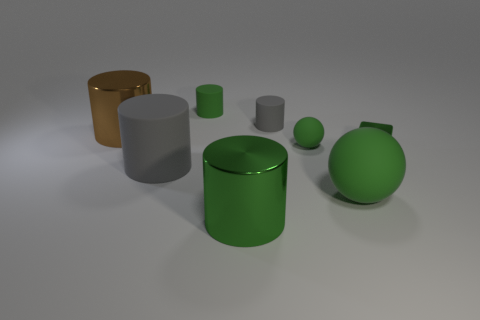Is the color of the big metal object that is to the right of the brown object the same as the small shiny thing?
Make the answer very short. Yes. Do the green metallic thing that is in front of the green cube and the large matte sphere have the same size?
Your answer should be very brief. Yes. What shape is the big thing that is both behind the big green rubber sphere and in front of the tiny green ball?
Offer a terse response. Cylinder. There is a big ball; is it the same color as the shiny object on the left side of the big green shiny object?
Your response must be concise. No. What color is the small block behind the large metallic object in front of the shiny cylinder behind the big gray rubber cylinder?
Keep it short and to the point. Green. What color is the other large metallic object that is the same shape as the brown thing?
Provide a short and direct response. Green. Are there an equal number of large gray things that are behind the green rubber cylinder and large yellow things?
Offer a very short reply. Yes. How many balls are either things or small brown objects?
Provide a succinct answer. 2. There is another cylinder that is made of the same material as the large green cylinder; what color is it?
Provide a short and direct response. Brown. Is the material of the large gray thing the same as the tiny cylinder that is behind the tiny gray thing?
Keep it short and to the point. Yes. 